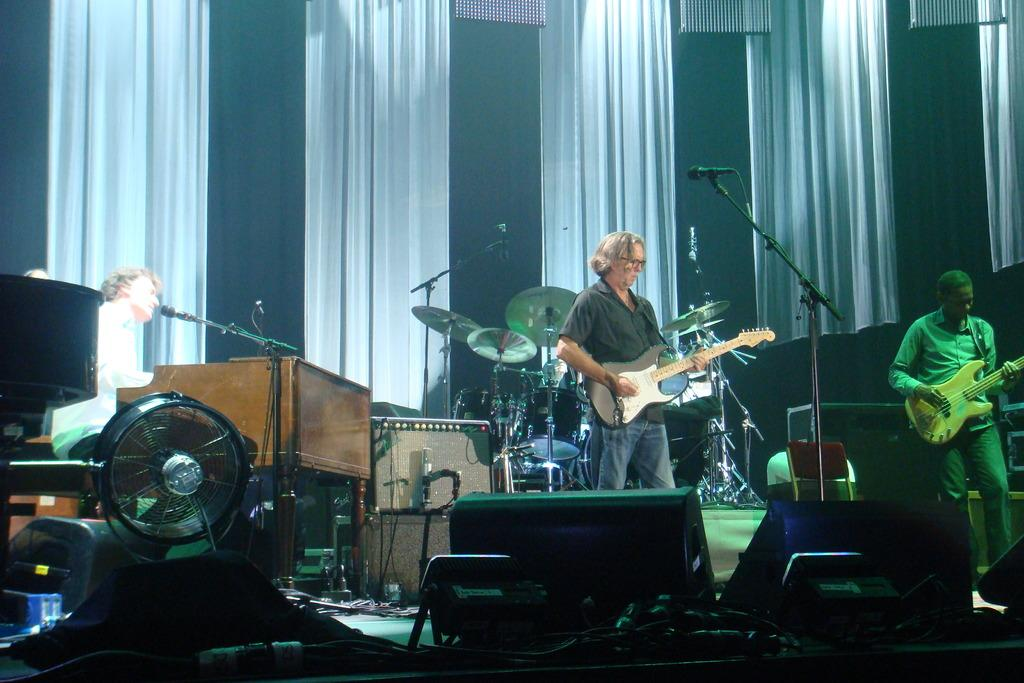What is the man in the image doing? The man is playing a guitar in the image. What else can be seen in the image related to music? There are other musical instruments and two other people playing music in the image. What can be seen in the background of the image? There are curtains in the background of the image. What type of throat condition does the man playing the guitar have in the image? There is no information about the man's throat condition in the image, as it focuses on the musical activity. 